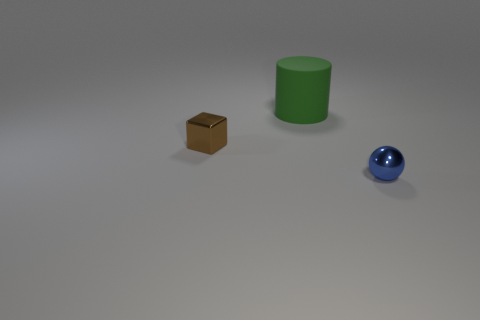What is the color of the small object that is on the right side of the thing that is behind the brown cube?
Your answer should be very brief. Blue. Is the shape of the brown metallic object the same as the rubber thing that is behind the small blue metal object?
Keep it short and to the point. No. What number of red spheres have the same size as the brown cube?
Offer a terse response. 0. There is a metal thing that is on the left side of the green cylinder; is its color the same as the thing that is in front of the shiny cube?
Offer a terse response. No. There is a small object that is in front of the tiny shiny cube; what shape is it?
Offer a terse response. Sphere. What color is the tiny ball?
Provide a succinct answer. Blue. The small blue object that is made of the same material as the brown object is what shape?
Make the answer very short. Sphere. There is a green matte object behind the brown metal cube; is its size the same as the tiny block?
Your response must be concise. No. How many objects are either small metal things that are right of the large object or small things that are on the right side of the tiny brown thing?
Your answer should be very brief. 1. There is a small object that is to the right of the large cylinder; is it the same color as the big matte object?
Your answer should be compact. No. 